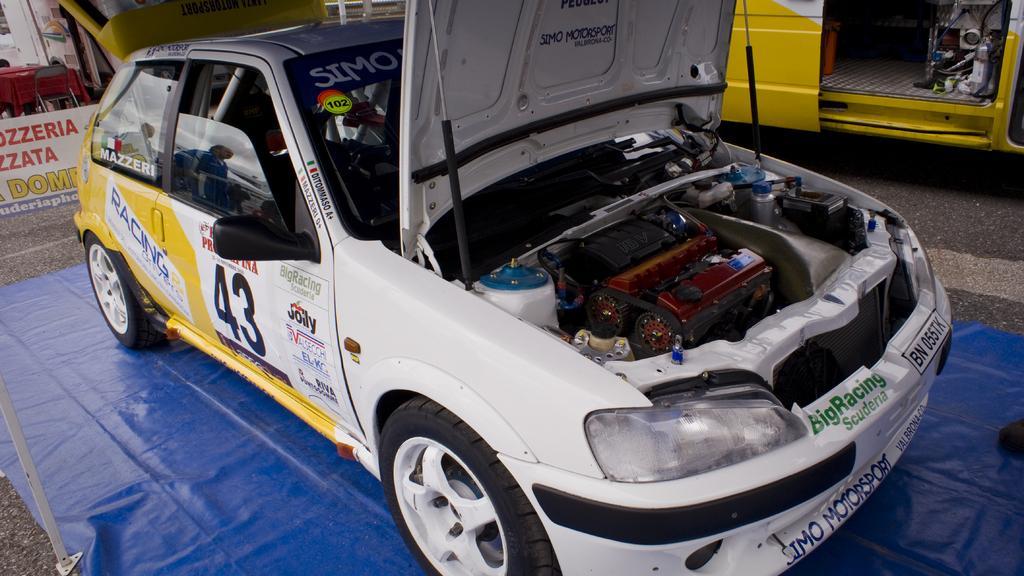Describe this image in one or two sentences. In this image, we can see a white color car and there is a blue color carpet on the floor. 